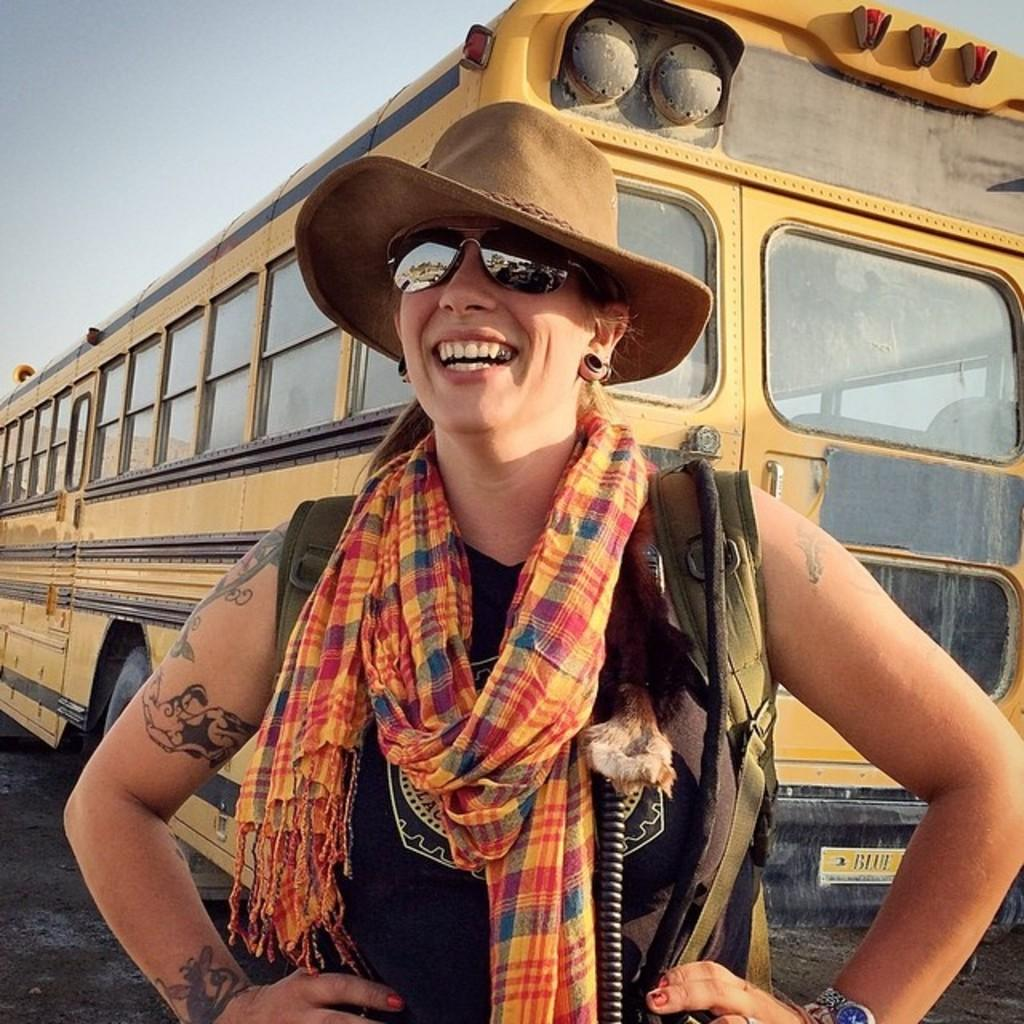Who is present in the image? There is a woman in the image. What is the woman doing in the image? The woman is smiling in the image. What accessories is the woman wearing in the image? The woman is wearing a cap and spectacles in the image. What can be seen in the background of the image? There is a bus in the background of the image. What type of wilderness can be seen in the background of the image? There is no wilderness present in the image; it features a woman and a bus in the background. How does the air affect the woman's hair in the image? There is no mention of air or its effect on the woman's hair in the image. 